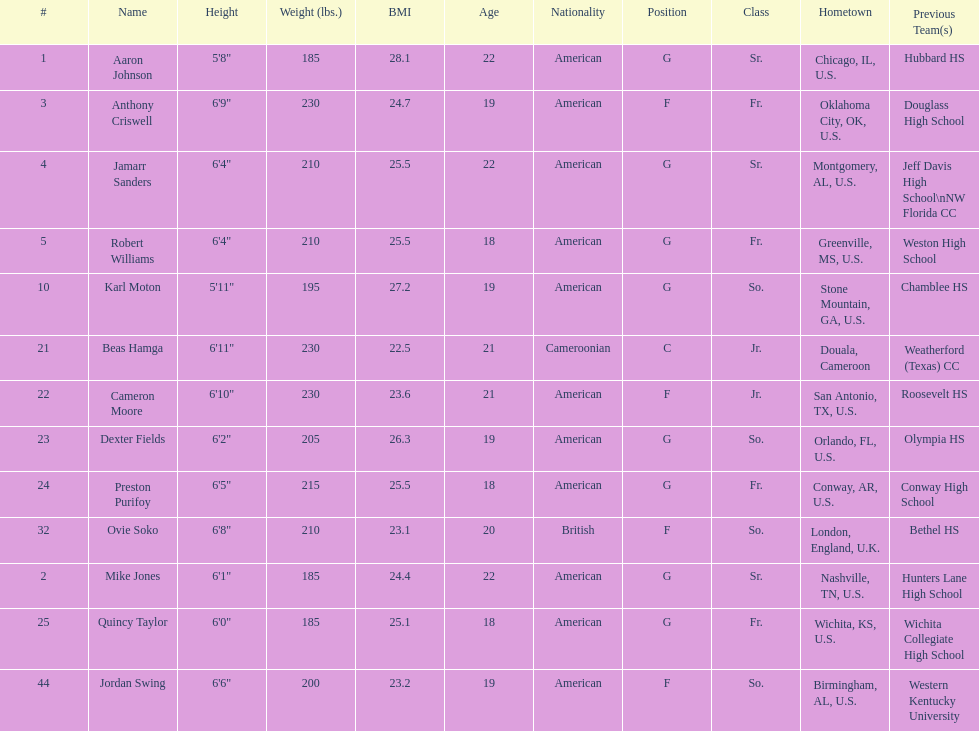Other than soko, tell me a player who is not from the us. Beas Hamga. 